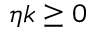Convert formula to latex. <formula><loc_0><loc_0><loc_500><loc_500>\eta k \geq 0</formula> 